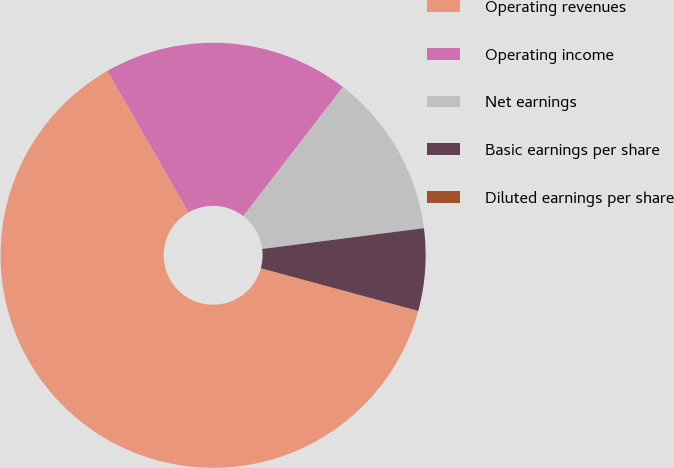<chart> <loc_0><loc_0><loc_500><loc_500><pie_chart><fcel>Operating revenues<fcel>Operating income<fcel>Net earnings<fcel>Basic earnings per share<fcel>Diluted earnings per share<nl><fcel>62.5%<fcel>18.75%<fcel>12.5%<fcel>6.25%<fcel>0.0%<nl></chart> 